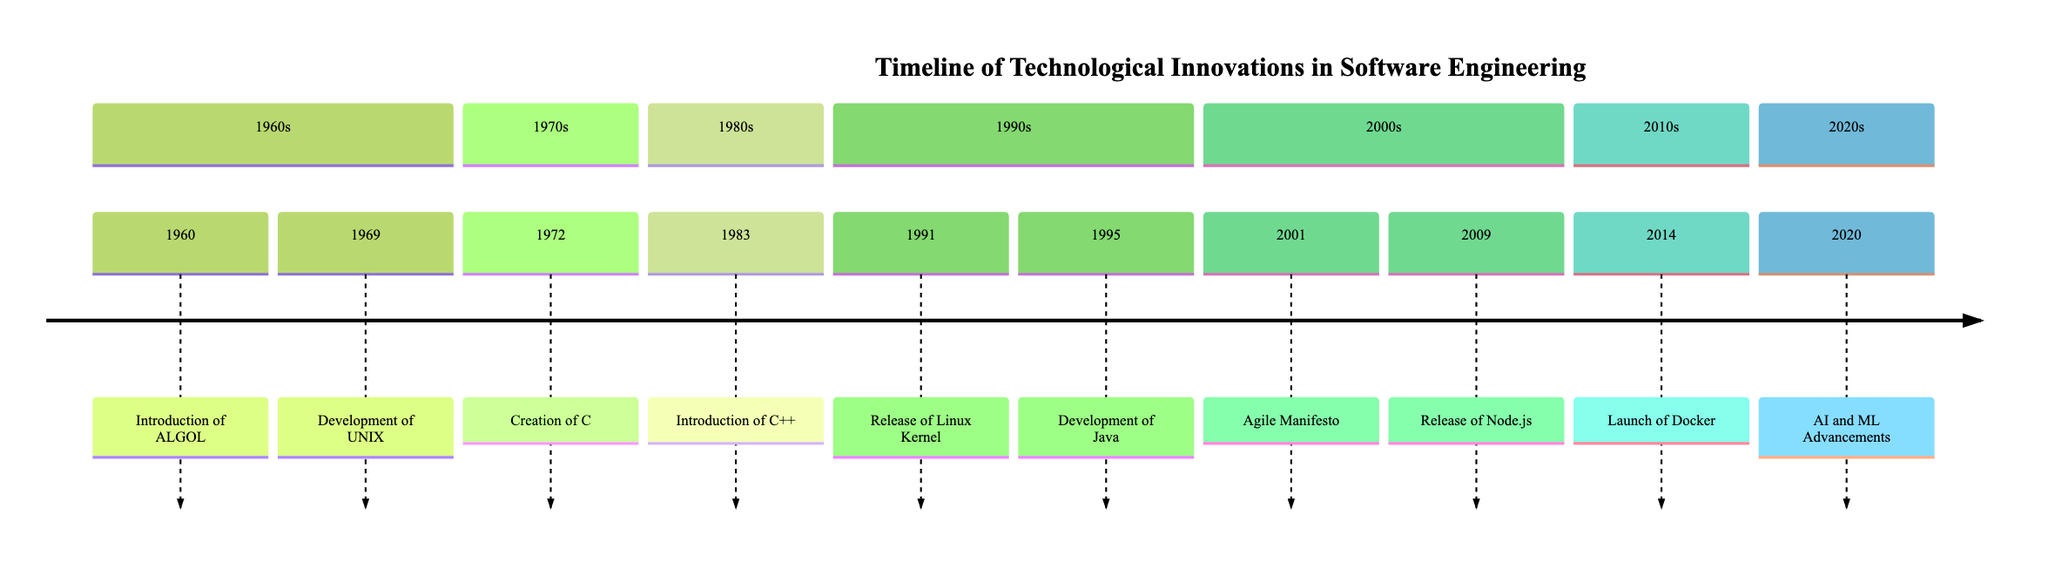What was introduced in 1960? The diagram specifies the event in 1960 as 'Introduction of ALGOL', which is listed clearly under the 1960s section.
Answer: Introduction of ALGOL What significant operating system was developed in 1969? According to the timeline, the event for 1969 is 'Development of UNIX', indicating a significant milestone in operating systems.
Answer: Development of UNIX How many events are listed in the 1990s section? By examining the 1990s section, there are two events listed: 'Release of Linux Kernel' in 1991 and 'Development of Java' in 1995. Thus, the total is two events.
Answer: 2 Which programming language was created in 1972? The timeline indicates that in 1972, the event is the 'Creation of C', providing the specific programming language introduced that year.
Answer: C Which event marks the introduction of Object-Oriented Programming? The event associated with the introduction of Object-Oriented Programming is 'Introduction of C++' which is listed under the 1980s section, specifically in 1983.
Answer: Introduction of C++ What was released in 2001 that focused on software development methodologies? In 2001, the timeline indicates the publication of the 'Agile Manifesto', which emphasizes methodologies in software development, thus answering the question.
Answer: Agile Manifesto In which year was Docker launched? The timeline clearly states that Docker was launched in 2014, which answers the question directly.
Answer: 2014 What is the significance of Node.js released in 2009? The description for Node.js, released in 2009, explains that it allowed JavaScript to be used for server-side scripting, highlighting its significance in web development.
Answer: Server-side JavaScript What decade saw advancements in Artificial Intelligence and Machine Learning? The diagram illustrates that advancements in AI and ML occurred in 2020, clearly indicating it was in the 2020s decade.
Answer: 2020s 